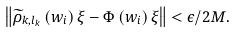Convert formula to latex. <formula><loc_0><loc_0><loc_500><loc_500>\left \| \widetilde { \rho } _ { k , l _ { k } } \left ( w _ { i } \right ) \xi - \Phi \left ( w _ { i } \right ) \xi \right \| < \epsilon / 2 M .</formula> 